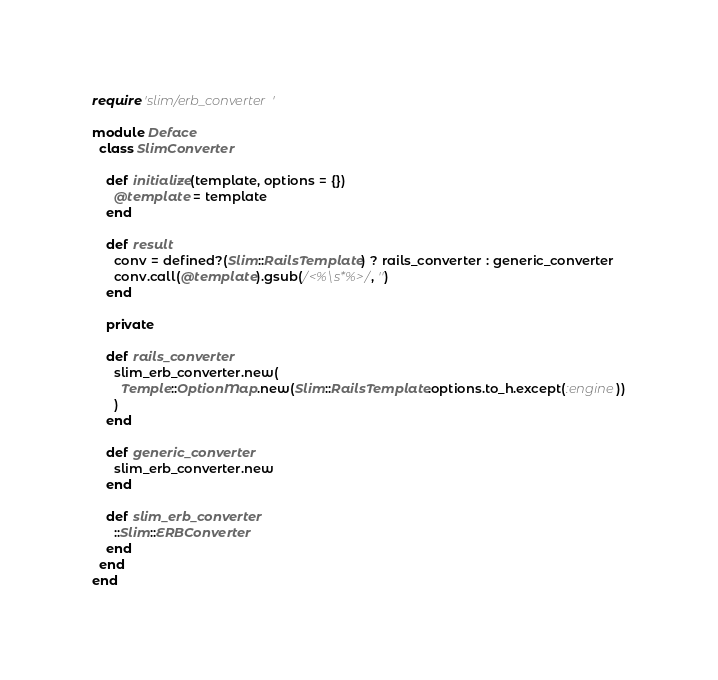Convert code to text. <code><loc_0><loc_0><loc_500><loc_500><_Ruby_>require 'slim/erb_converter'

module Deface
  class SlimConverter

    def initialize(template, options = {})
      @template = template
    end

    def result
      conv = defined?(Slim::RailsTemplate) ? rails_converter : generic_converter
      conv.call(@template).gsub(/<%\s*%>/, '')
    end

    private

    def rails_converter
      slim_erb_converter.new(
        Temple::OptionMap.new(Slim::RailsTemplate.options.to_h.except(:engine))
      )
    end

    def generic_converter
      slim_erb_converter.new
    end

    def slim_erb_converter
      ::Slim::ERBConverter
    end
  end
end
</code> 